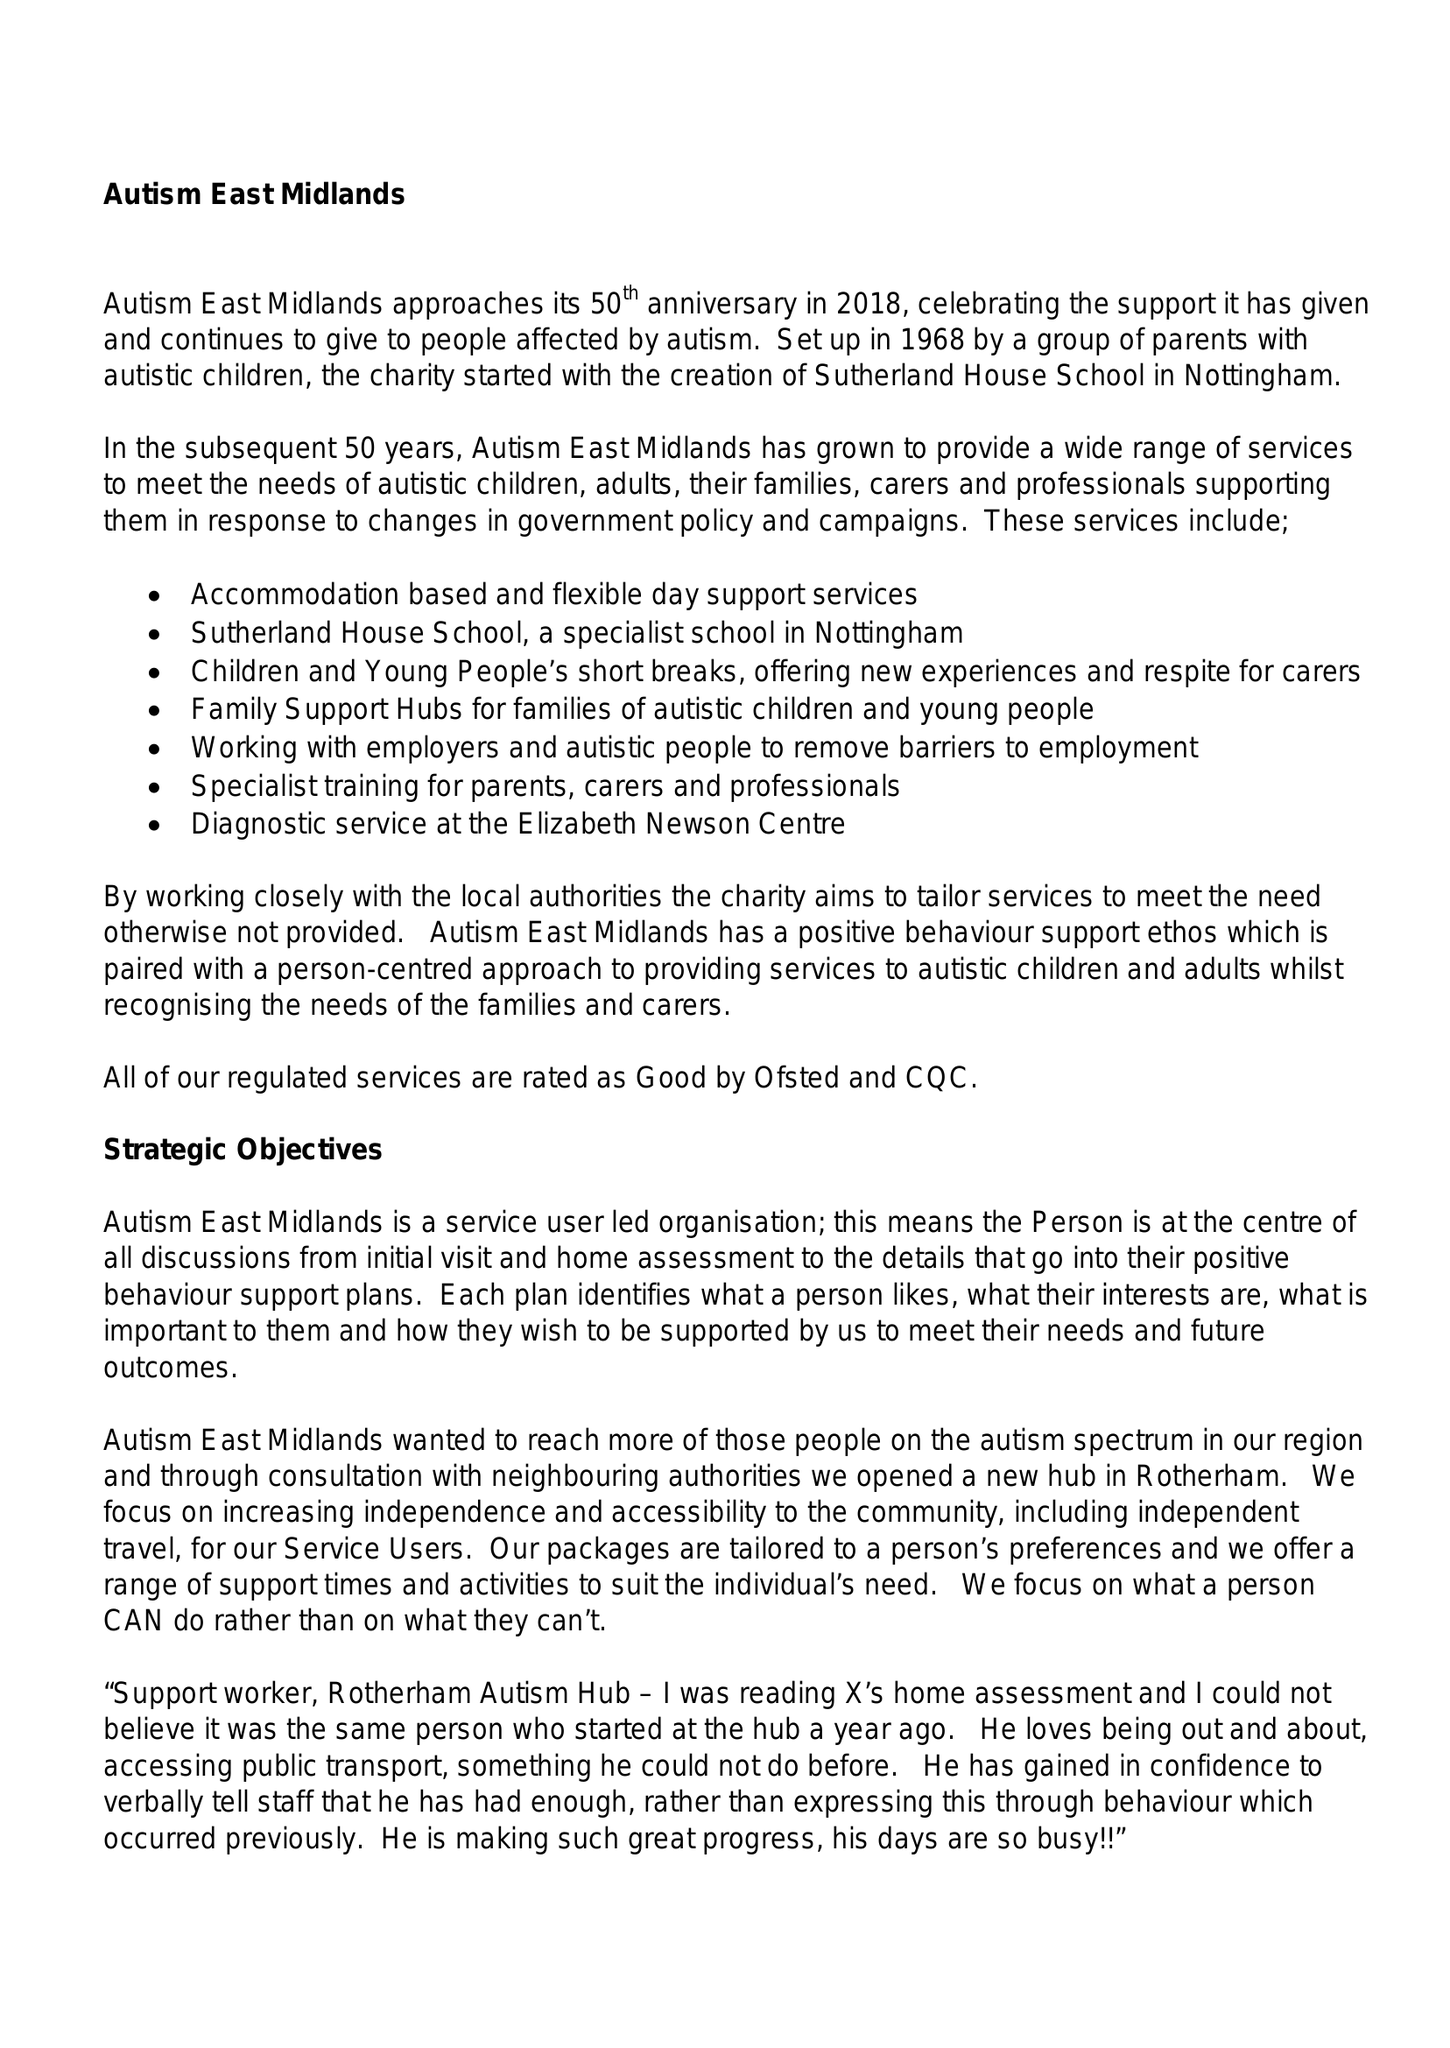What is the value for the address__post_town?
Answer the question using a single word or phrase. WORKSOP 